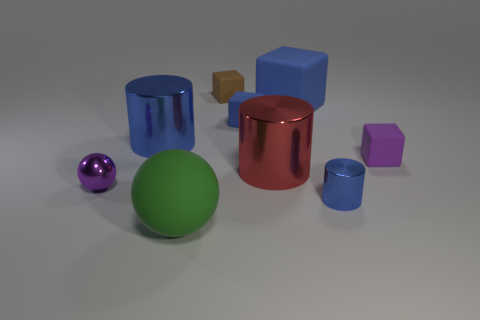Subtract all blue cylinders. How many cylinders are left? 1 Add 1 large purple metal blocks. How many objects exist? 10 Subtract all green blocks. How many blue cylinders are left? 2 Subtract 1 cylinders. How many cylinders are left? 2 Subtract all blue cylinders. How many cylinders are left? 1 Subtract all cubes. How many objects are left? 5 Subtract all blue cylinders. Subtract all yellow balls. How many cylinders are left? 1 Subtract all blue shiny cylinders. Subtract all big blue cylinders. How many objects are left? 6 Add 7 small metallic cylinders. How many small metallic cylinders are left? 8 Add 4 purple rubber spheres. How many purple rubber spheres exist? 4 